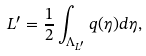<formula> <loc_0><loc_0><loc_500><loc_500>L ^ { \prime } = \frac { 1 } { 2 } \int _ { \Lambda _ { L ^ { \prime } } } q ( \eta ) d \eta ,</formula> 